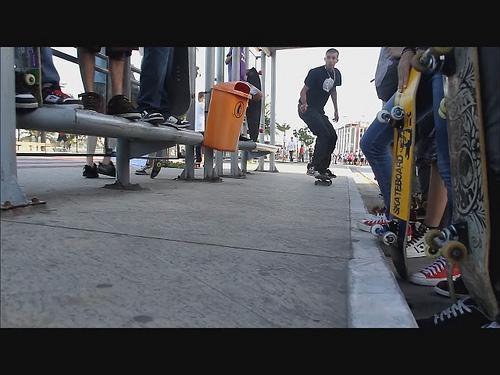How many skateboards are shown?
Give a very brief answer. 7. 